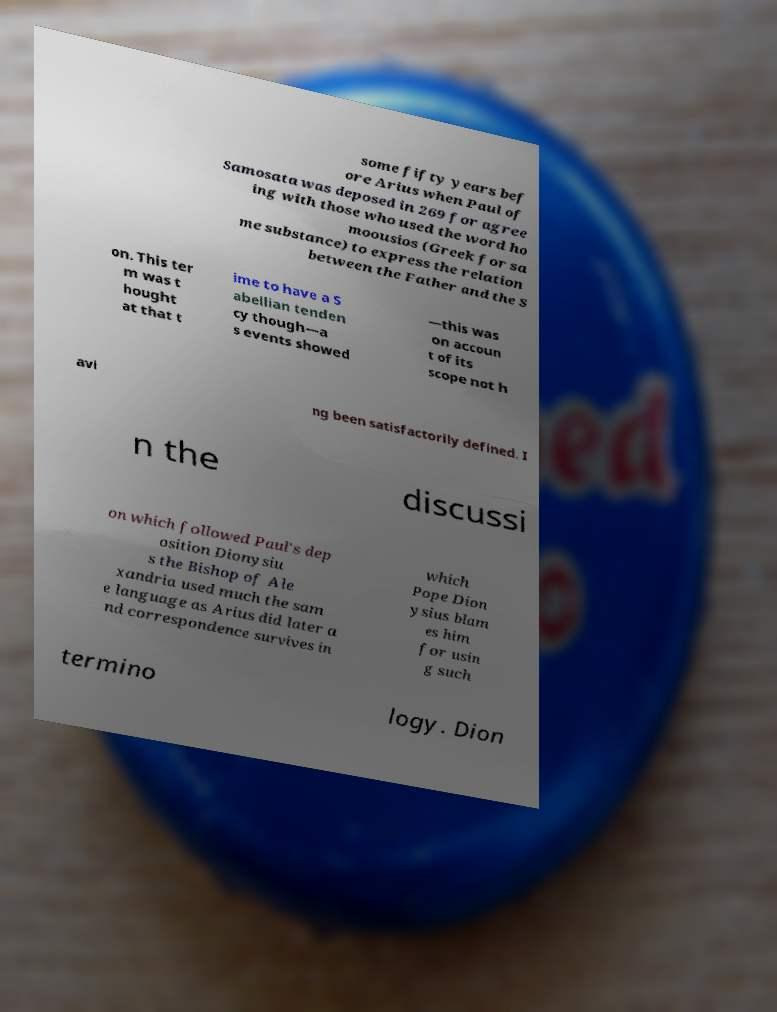Please read and relay the text visible in this image. What does it say? some fifty years bef ore Arius when Paul of Samosata was deposed in 269 for agree ing with those who used the word ho moousios (Greek for sa me substance) to express the relation between the Father and the S on. This ter m was t hought at that t ime to have a S abellian tenden cy though—a s events showed —this was on accoun t of its scope not h avi ng been satisfactorily defined. I n the discussi on which followed Paul's dep osition Dionysiu s the Bishop of Ale xandria used much the sam e language as Arius did later a nd correspondence survives in which Pope Dion ysius blam es him for usin g such termino logy. Dion 